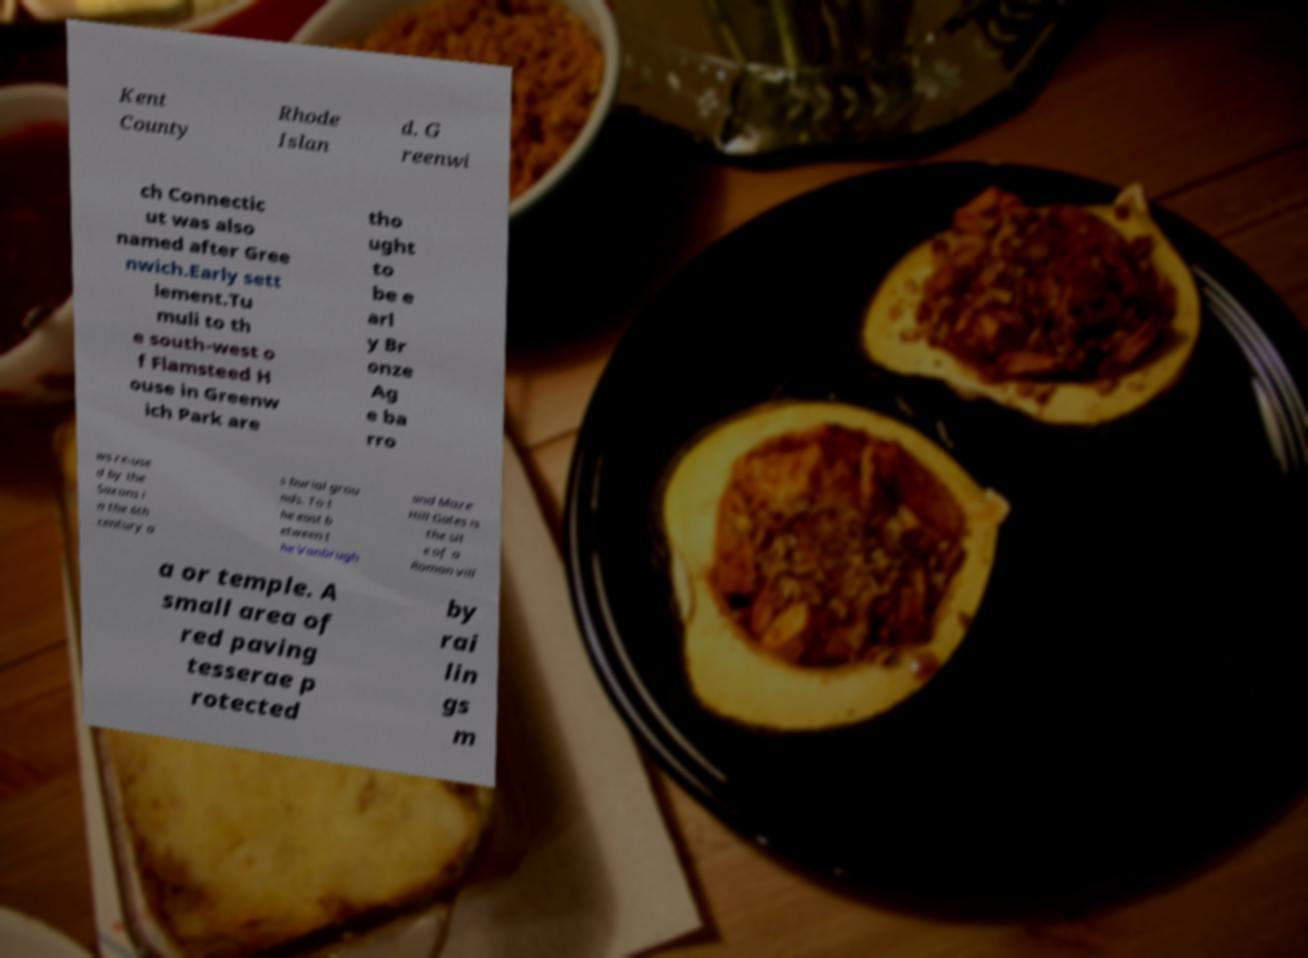For documentation purposes, I need the text within this image transcribed. Could you provide that? Kent County Rhode Islan d. G reenwi ch Connectic ut was also named after Gree nwich.Early sett lement.Tu muli to th e south-west o f Flamsteed H ouse in Greenw ich Park are tho ught to be e arl y Br onze Ag e ba rro ws re-use d by the Saxons i n the 6th century a s burial grou nds. To t he east b etween t he Vanbrugh and Maze Hill Gates is the sit e of a Roman vill a or temple. A small area of red paving tesserae p rotected by rai lin gs m 